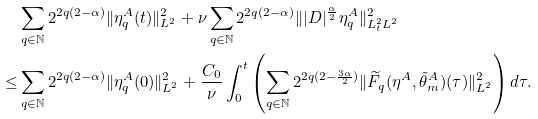<formula> <loc_0><loc_0><loc_500><loc_500>& \sum _ { q \in \mathbb { N } } 2 ^ { 2 q ( 2 - \alpha ) } \| \eta ^ { A } _ { q } ( t ) \| ^ { 2 } _ { L ^ { 2 } } + \nu \sum _ { q \in \mathbb { N } } 2 ^ { 2 q ( 2 - \alpha ) } \| | D | ^ { \frac { \alpha } { 2 } } \eta ^ { A } _ { q } \| _ { L ^ { 2 } _ { t } L ^ { 2 } } ^ { 2 } \\ \leq & \sum _ { q \in \mathbb { N } } 2 ^ { 2 q ( 2 - \alpha ) } \| \eta ^ { A } _ { q } ( 0 ) \| ^ { 2 } _ { L ^ { 2 } } + \frac { C _ { 0 } } { \nu } \int _ { 0 } ^ { t } \left ( \sum _ { q \in \mathbb { N } } 2 ^ { 2 q ( 2 - \frac { 3 \alpha } { 2 } ) } \| \widetilde { F } _ { q } ( \eta ^ { A } , \tilde { \theta } ^ { A } _ { m } ) ( \tau ) \| ^ { 2 } _ { L ^ { 2 } } \right ) d \tau .</formula> 